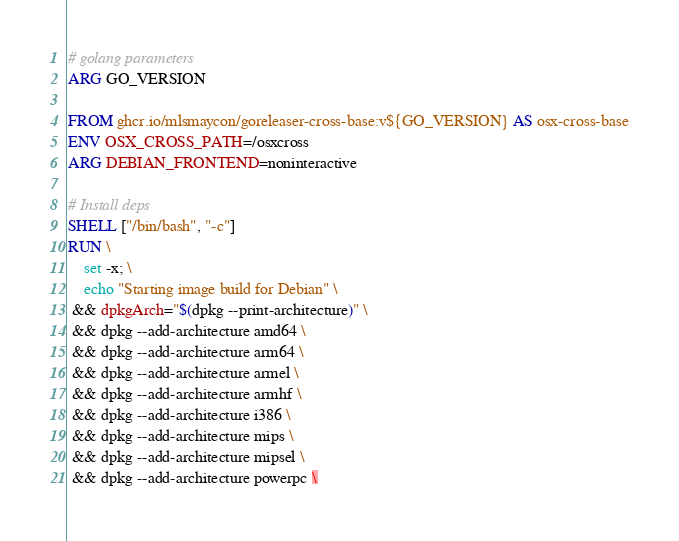Convert code to text. <code><loc_0><loc_0><loc_500><loc_500><_Dockerfile_># golang parameters
ARG GO_VERSION

FROM ghcr.io/mlsmaycon/goreleaser-cross-base:v${GO_VERSION} AS osx-cross-base
ENV OSX_CROSS_PATH=/osxcross
ARG DEBIAN_FRONTEND=noninteractive

# Install deps
SHELL ["/bin/bash", "-c"]
RUN \
    set -x; \
    echo "Starting image build for Debian" \
 && dpkgArch="$(dpkg --print-architecture)" \
 && dpkg --add-architecture amd64 \
 && dpkg --add-architecture arm64 \
 && dpkg --add-architecture armel \
 && dpkg --add-architecture armhf \
 && dpkg --add-architecture i386 \
 && dpkg --add-architecture mips \
 && dpkg --add-architecture mipsel \
 && dpkg --add-architecture powerpc \</code> 